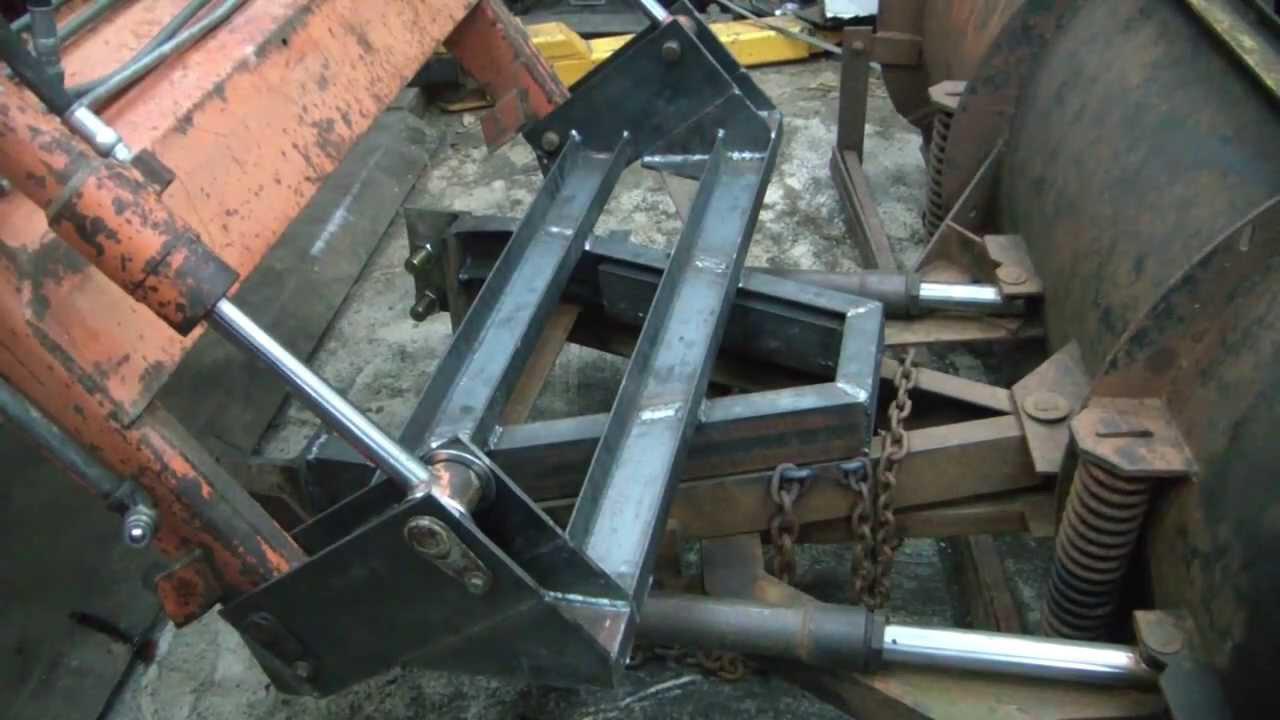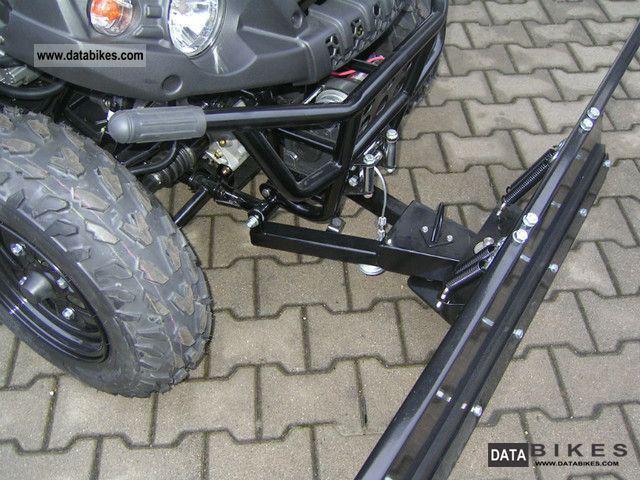The first image is the image on the left, the second image is the image on the right. Analyze the images presented: Is the assertion "At least one tire is visible in one of the images." valid? Answer yes or no. Yes. The first image is the image on the left, the second image is the image on the right. Considering the images on both sides, is "An image shows an attached snow plow on a snow-covered ground." valid? Answer yes or no. No. 